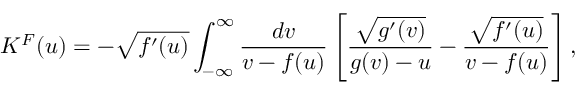Convert formula to latex. <formula><loc_0><loc_0><loc_500><loc_500>K ^ { F } ( u ) = - \sqrt { f ^ { \prime } ( u ) } \int _ { - \infty } ^ { \infty } \frac { d v } { v - f ( u ) } \left [ \frac { \sqrt { g ^ { \prime } ( v ) } } { g ( v ) - u } - \frac { \sqrt { f ^ { \prime } ( u ) } } { v - f ( u ) } \right ] ,</formula> 